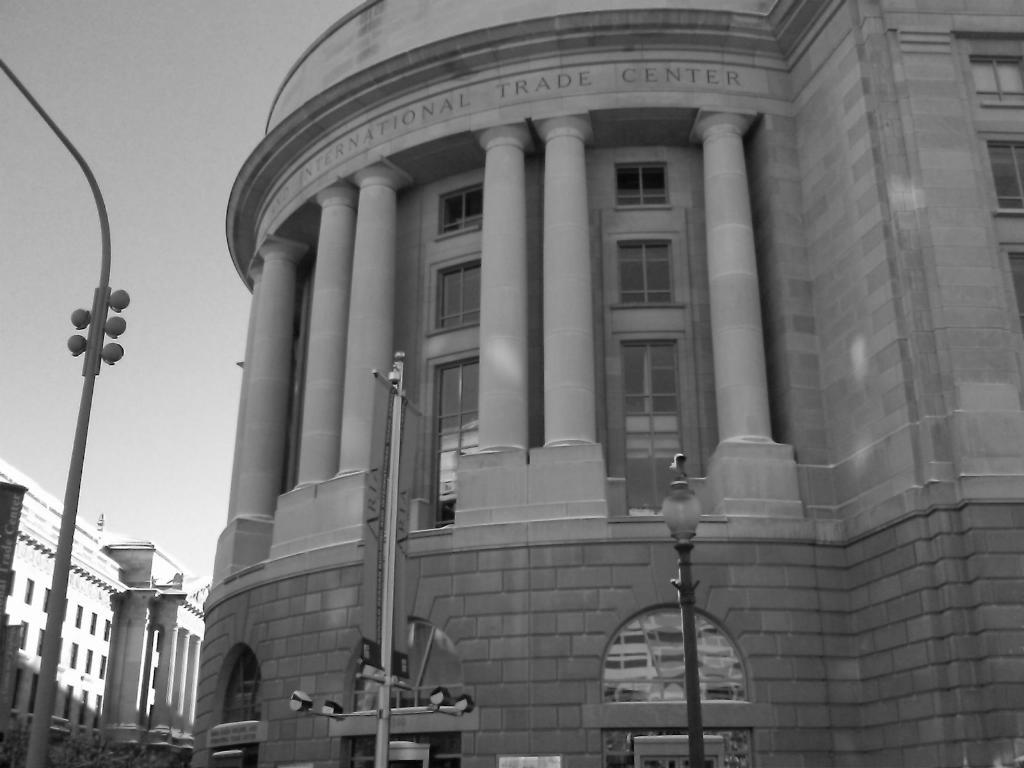What type of structures are present in the image? There are buildings in the image. What other objects can be seen in the image? There are poles visible in the image. What is visible in the background of the image? The sky is visible in the background of the image. How many legs can be seen on the governor in the image? There is no governor present in the image, so it is not possible to determine how many legs they might have. 